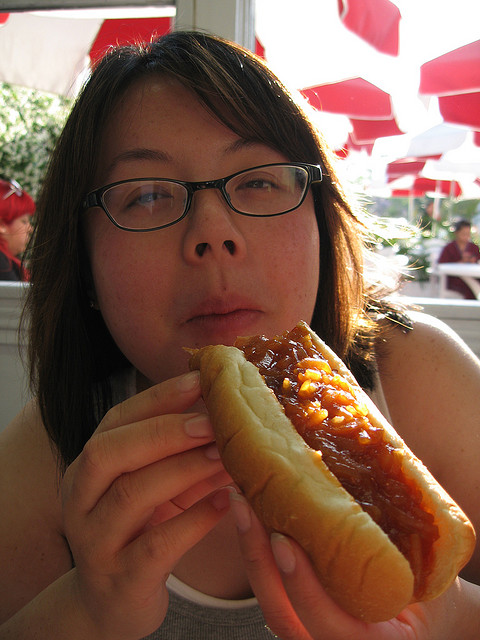What type of food is the person eating? The person is eating a hot dog with a generous amount of condiments on top. 